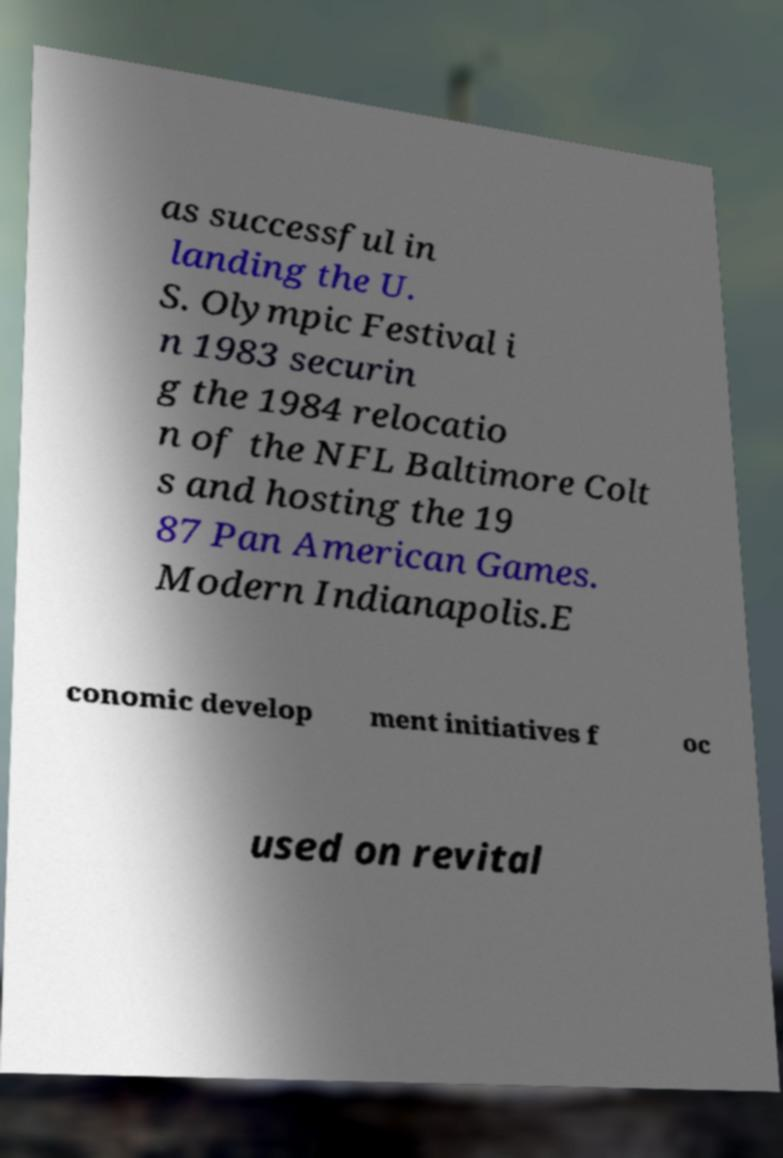I need the written content from this picture converted into text. Can you do that? as successful in landing the U. S. Olympic Festival i n 1983 securin g the 1984 relocatio n of the NFL Baltimore Colt s and hosting the 19 87 Pan American Games. Modern Indianapolis.E conomic develop ment initiatives f oc used on revital 